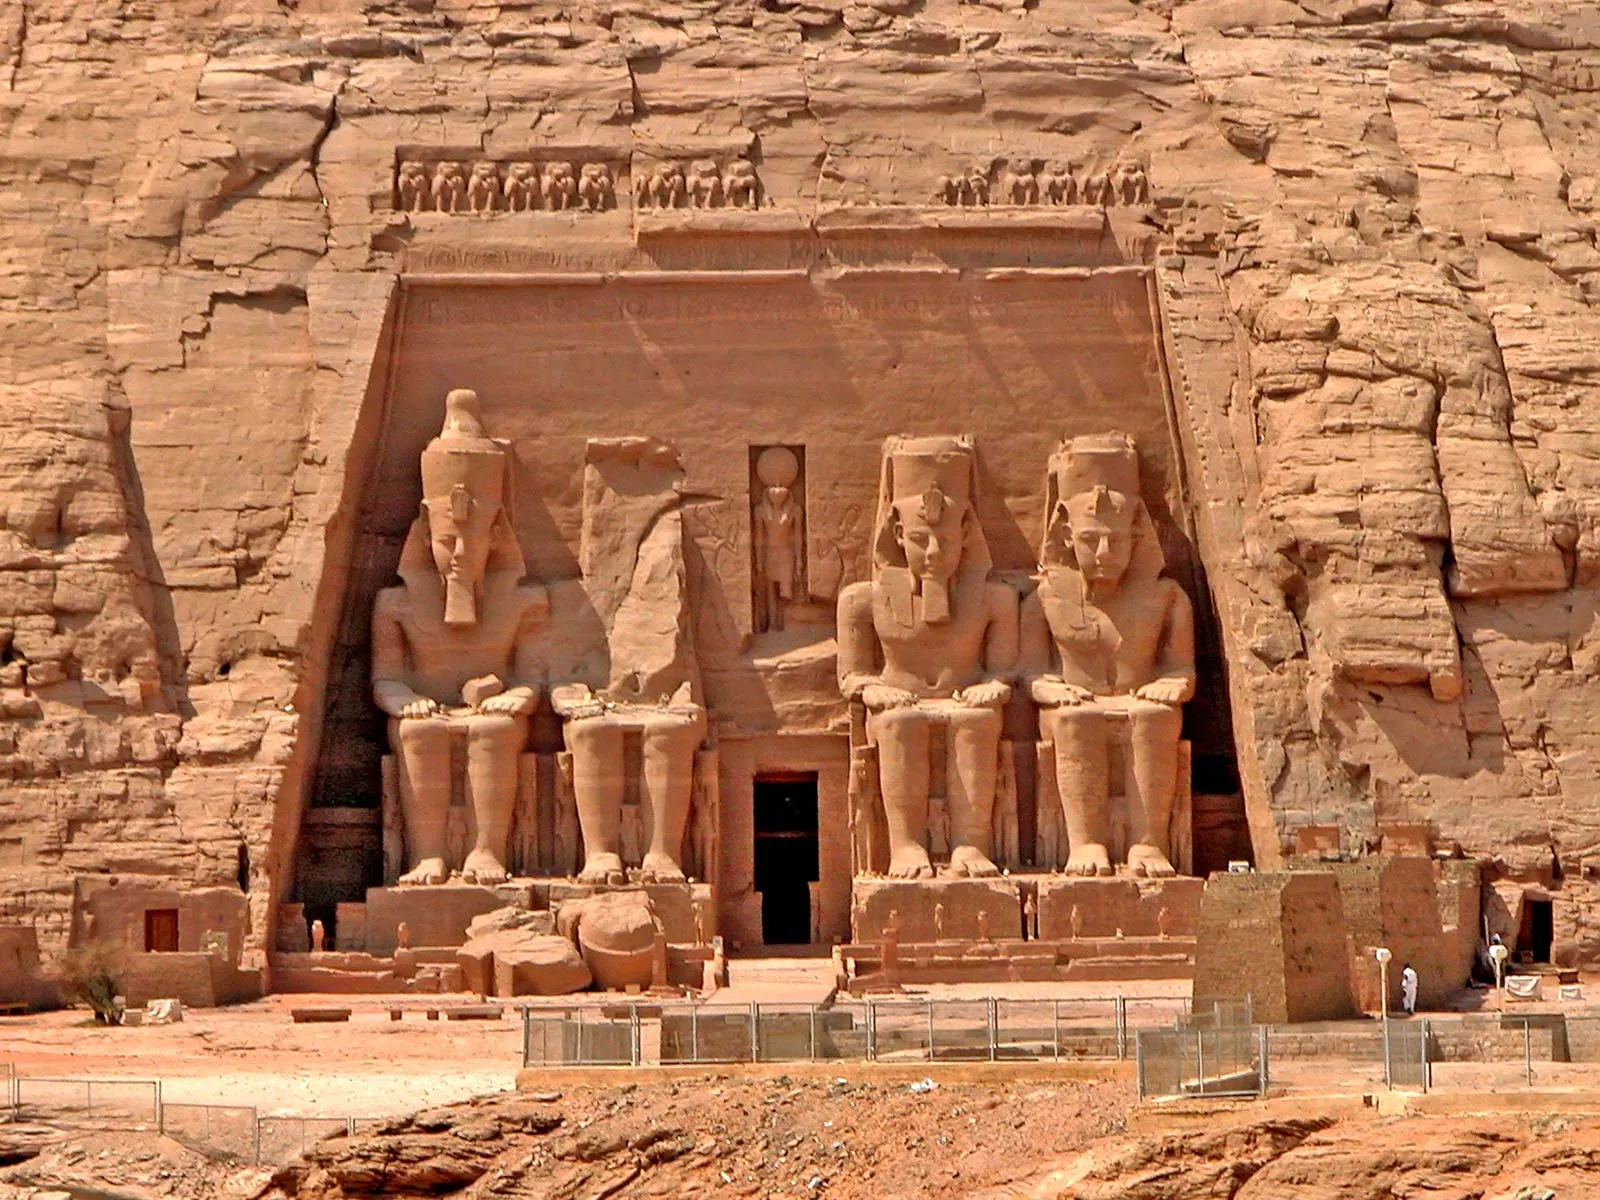What might the contrast between the temple’s ancient significance and the modern-day tourist experience look like? The contrast between the temple’s ancient significance and the modern-day tourist experience is striking. Visitors from around the world, equipped with digital cameras and smartphones, capture the timeless beauty of the colossal statues, sharing their experiences instantly on social media. Information boards and interactive apps provide historical context, translating hieroglyphs and explaining the significance of various carvings and structures. Modern amenities like shaded rest areas, hydration stations, and guided tours make the visit comfortable. Yet, despite these conveniences, the awe-inspiring grandeur of the temple, with its profound sense of history and spiritual resonance, remains undiminished. The profound reverence felt by ancient worshippers finds parallels in the hushed marvel of modern visitors, bridging centuries through shared human wonder. 